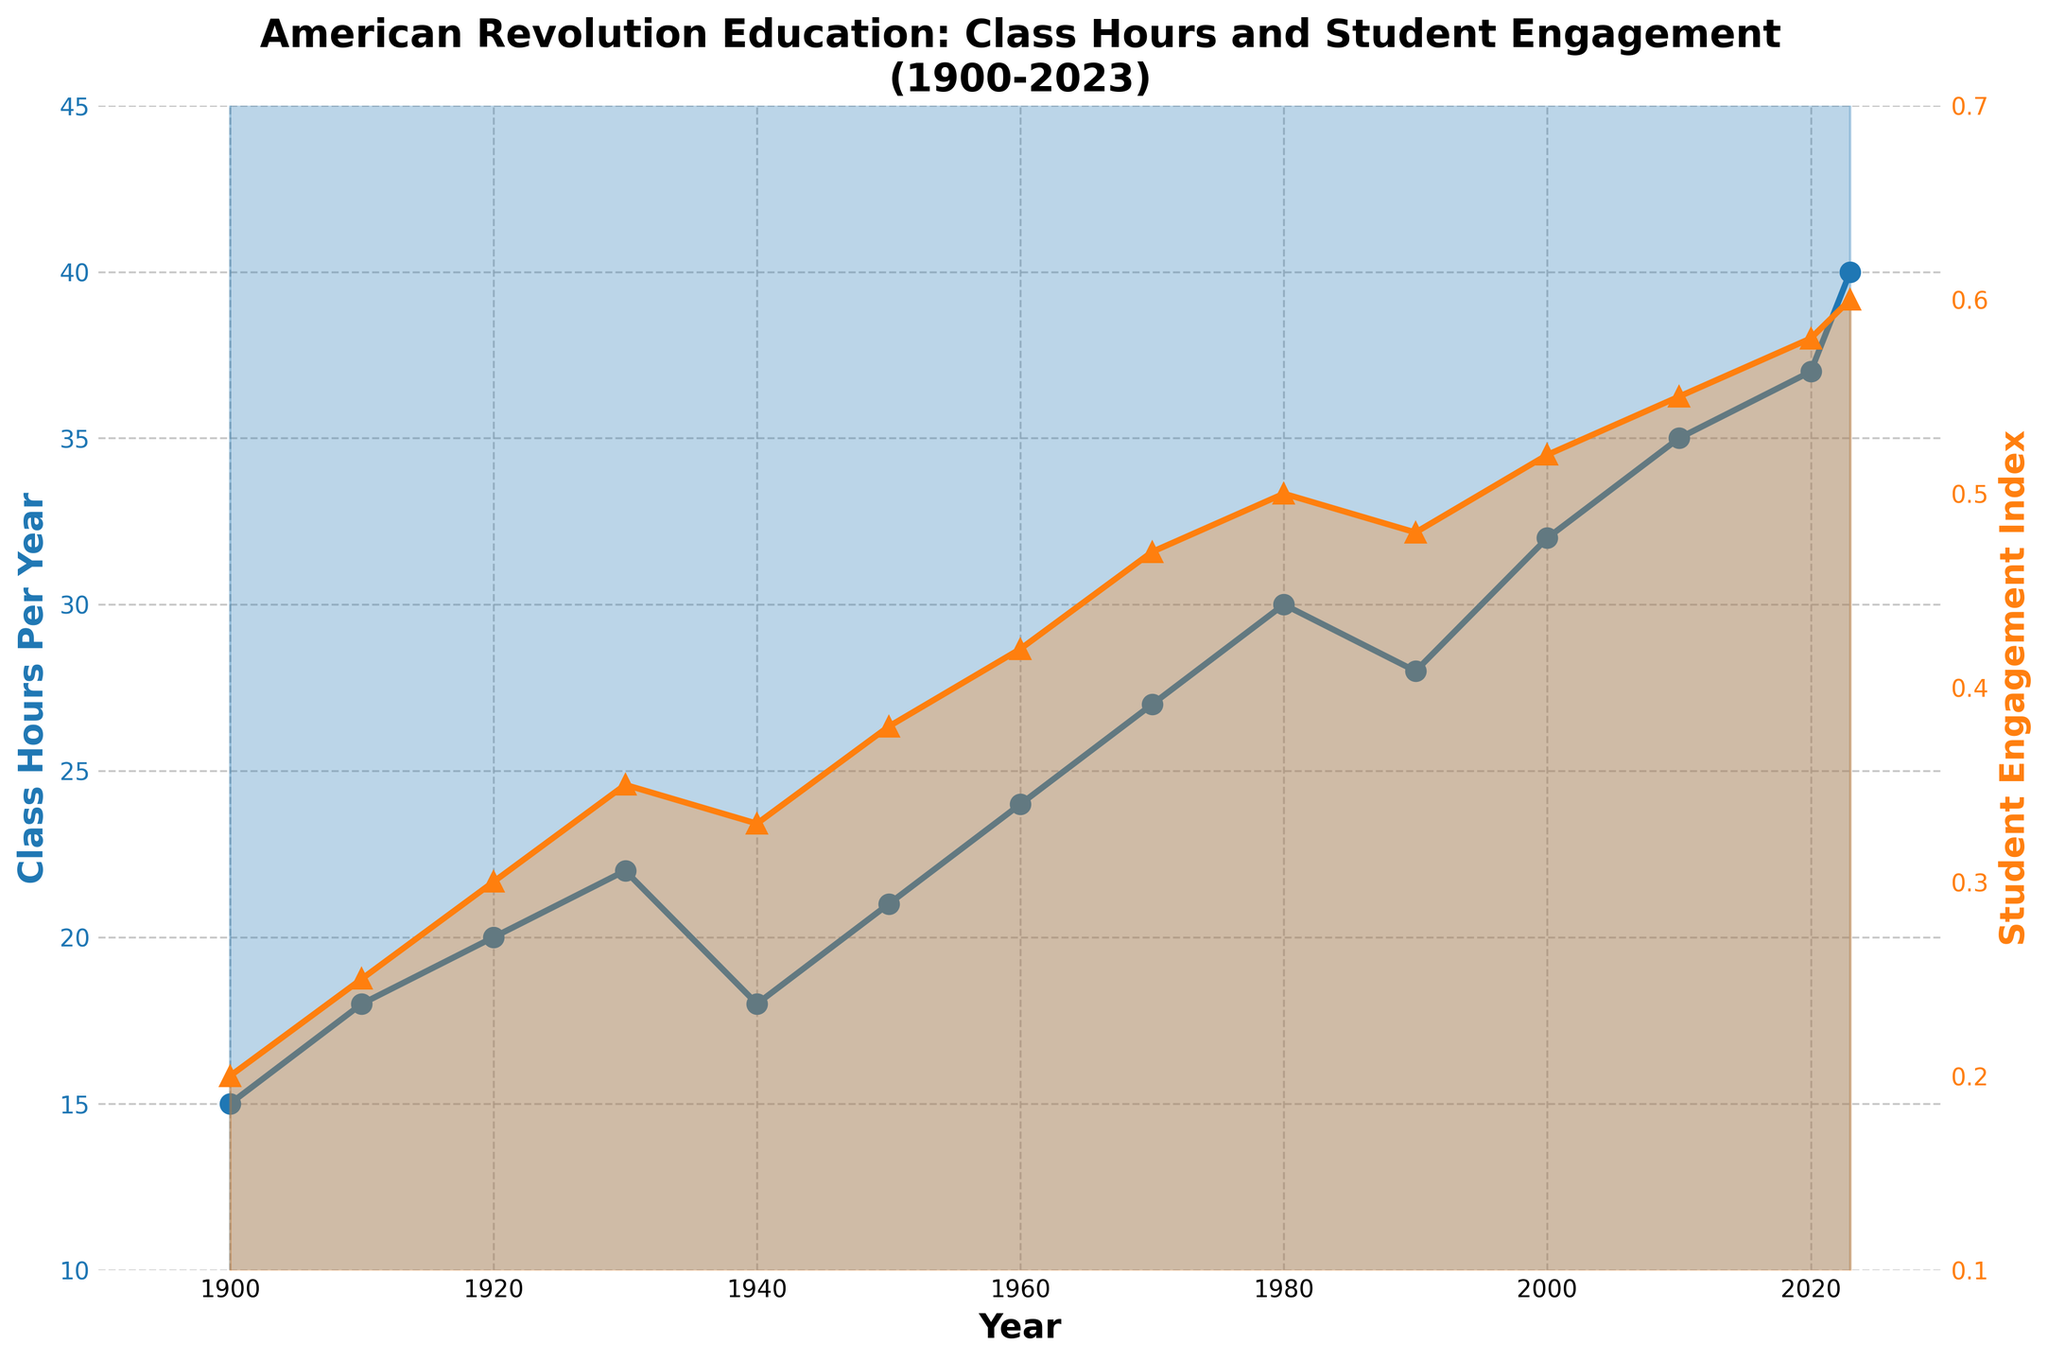What is the title of the figure? The title of the figure is "American Revolution Education: Class Hours and Student Engagement (1900-2023)" as seen at the top of the plot.
Answer: American Revolution Education: Class Hours and Student Engagement (1900-2023) How have class hours per year changed from 1900 to 2023? To find out how class hours per year have changed from 1900 to 2023, observe the blue line showing data on the left y-axis. Class hours per year have increased from 15 in 1900 to 40 in 2023.
Answer: Increased from 15 to 40 What can you infer about the trend in student engagement index from 1980 to 2023? To infer the trend, look at the orange line showing data on the right y-axis from 1980 to 2023. The student engagement index increased from 0.5 to 0.6, showing a rising trend.
Answer: Increasing trend What is the difference in class hours per year between 1990 and 2023? Look at the blue data points for 1990 and 2023. In 1990, class hours per year were 28, and in 2023, they were 40. The difference is 40 - 28 = 12.
Answer: 12 During which decade did student engagement see the highest increase? To find the decade with the highest increase, compare the slopes of the orange line in each decade. The steepest increase occurs from 2000 to 2010, increasing from 0.52 to 0.55.
Answer: 2000-2010 Compare the class hours per year and the student engagement index in 1940. What do you observe? In 1940, the blue line shows class hours per year are 18, and the orange line shows the student engagement index is 0.33. Comparing them shows a moderate engagement level relative to class hours.
Answer: 18 class hours, 0.33 engagement index What is the average class hours per year from 1900 to 1950? Calculate the average for class hours per year between 1900 and 1950: (15 + 18 + 20 + 22 + 18 + 21)/6 = 114/6 = 19.
Answer: 19 What was the student engagement index in 1980 compared to 2000? In 1980, the student engagement index was 0.5, and in 2000, it was 0.52. Comparing these values, the index increased slightly.
Answer: Increased from 0.5 to 0.52 By how much did class hours per year increase from 1960 to 1980? In 1960, class hours per year were 24, and in 1980, they were 30. The increase is 30 - 24 = 6.
Answer: 6 How many years show both a positive increase in class hours per year and an increase in the student engagement index? Count years when both class hours per year and student engagement index increased: Class hours increased in 1900, 1910, 1920, 1930, 1950, 1960, 1970, 1980, 2000, 2010, 2020, 2023. Corresponding years for engagement: 1900, 1910, 1920, 1930, 1950, 1960, 1970, 1980, 2000, 2010, 2020, 2023. All 12 years meet both conditions.
Answer: 12 